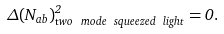Convert formula to latex. <formula><loc_0><loc_0><loc_500><loc_500>\Delta ( N _ { a b } ) ^ { 2 } _ { \mathrm t w o \ m o d e \ s q u e e z e d \ l i g h t } = 0 .</formula> 